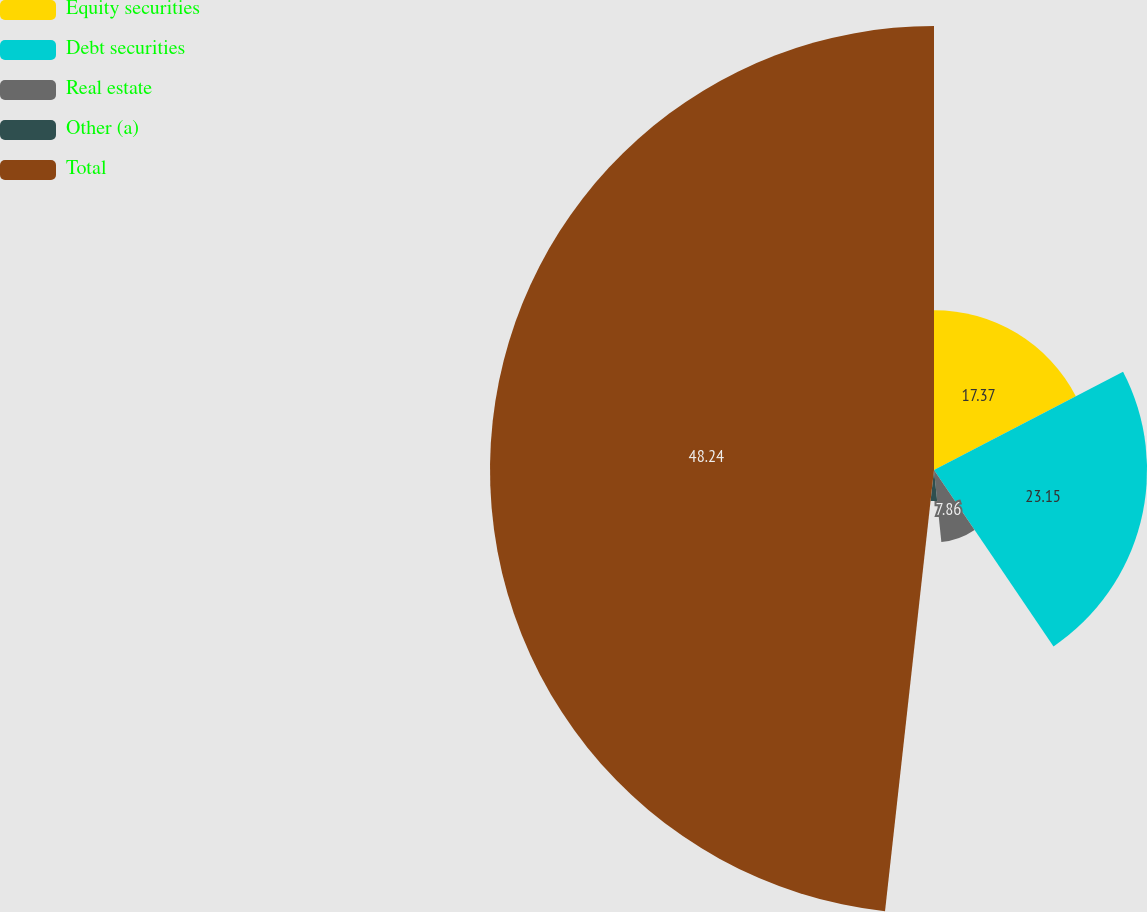Convert chart. <chart><loc_0><loc_0><loc_500><loc_500><pie_chart><fcel>Equity securities<fcel>Debt securities<fcel>Real estate<fcel>Other (a)<fcel>Total<nl><fcel>17.37%<fcel>23.15%<fcel>7.86%<fcel>3.38%<fcel>48.24%<nl></chart> 